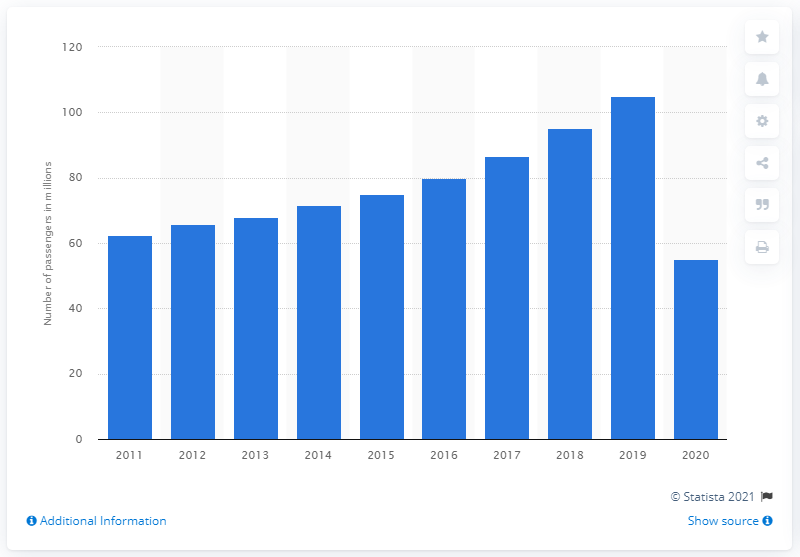Highlight a few significant elements in this photo. In 2020, a total of 55.1 seats were flown on easyJet flights. 